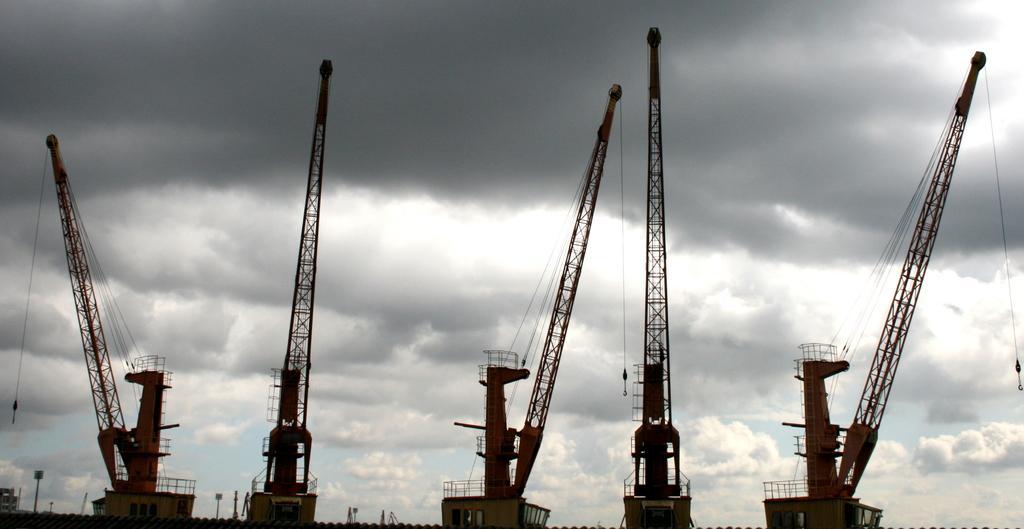Describe this image in one or two sentences. This picture shows few cranes and we see a blue cloudy sky. 